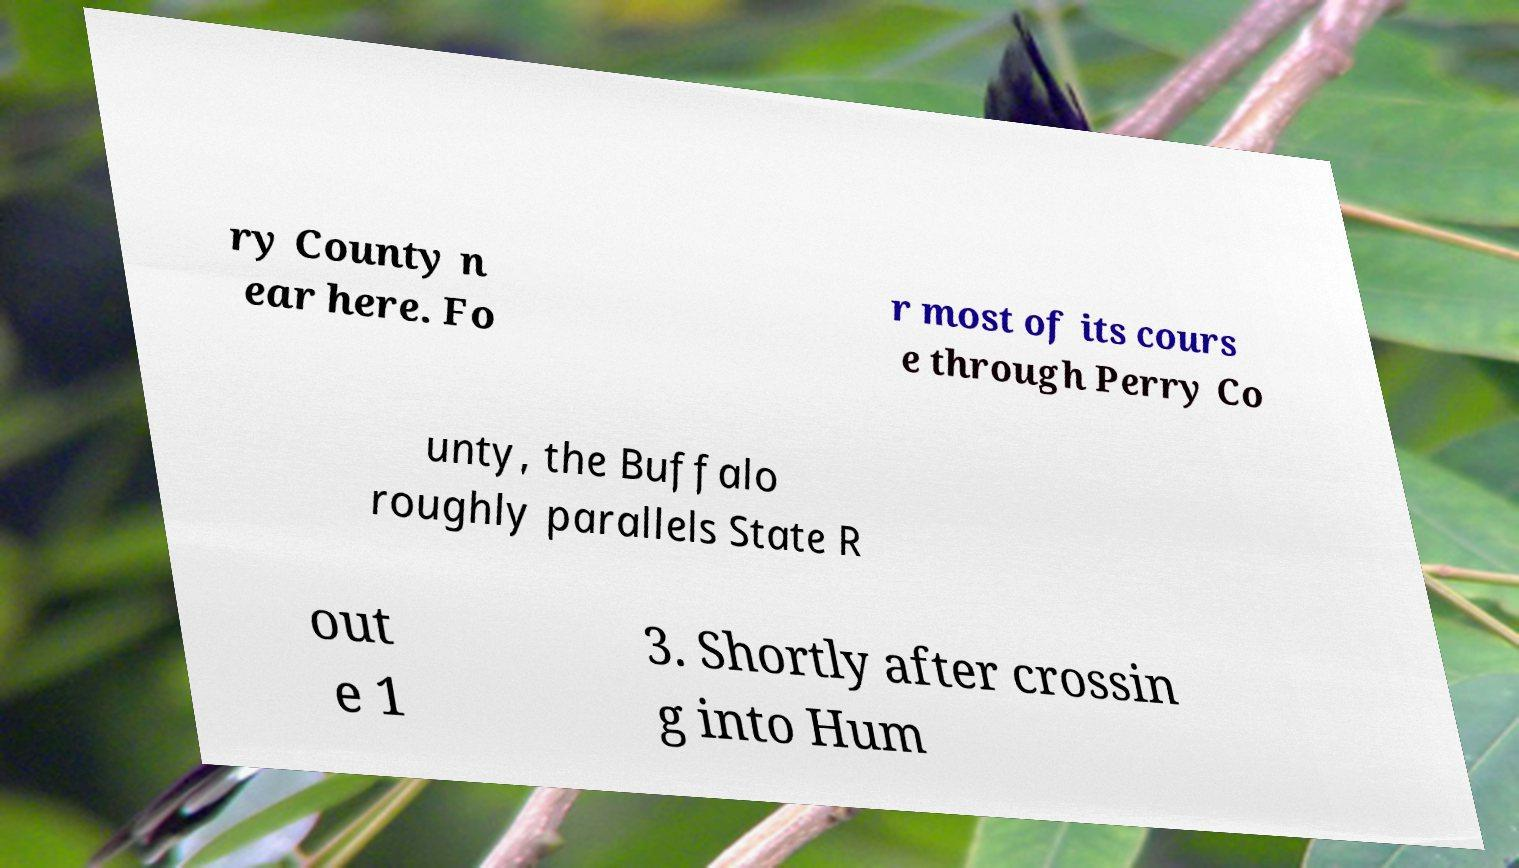I need the written content from this picture converted into text. Can you do that? ry County n ear here. Fo r most of its cours e through Perry Co unty, the Buffalo roughly parallels State R out e 1 3. Shortly after crossin g into Hum 